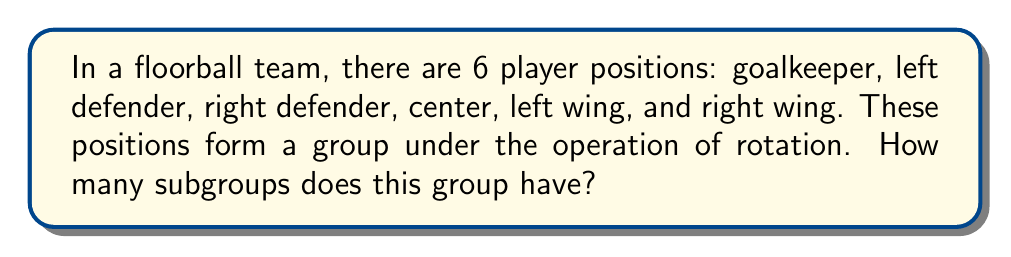Teach me how to tackle this problem. Let's approach this step-by-step:

1) First, we need to recognize that this group is isomorphic to the cyclic group $C_6$ (the group of rotations of a regular hexagon).

2) To find the number of subgroups, we need to find the divisors of 6, as each subgroup will have an order that divides the order of the main group.

3) The divisors of 6 are 1, 2, 3, and 6.

4) For each divisor $d$, there is exactly one subgroup of order $d$:
   - For $d=1$: The trivial subgroup $\{e\}$ (where $e$ is the identity element)
   - For $d=2$: The subgroup $\{e, r^3\}$ (where $r$ is a rotation by 60°)
   - For $d=3$: The subgroup $\{e, r^2, r^4\}$
   - For $d=6$: The entire group

5) Therefore, the total number of subgroups is equal to the number of divisors of 6, which is 4.

This result is consistent with the general formula for the number of subgroups in a cyclic group $C_n$, which is equal to the number of divisors of $n$.
Answer: The group representing the 6 player positions in floorball has 4 subgroups. 